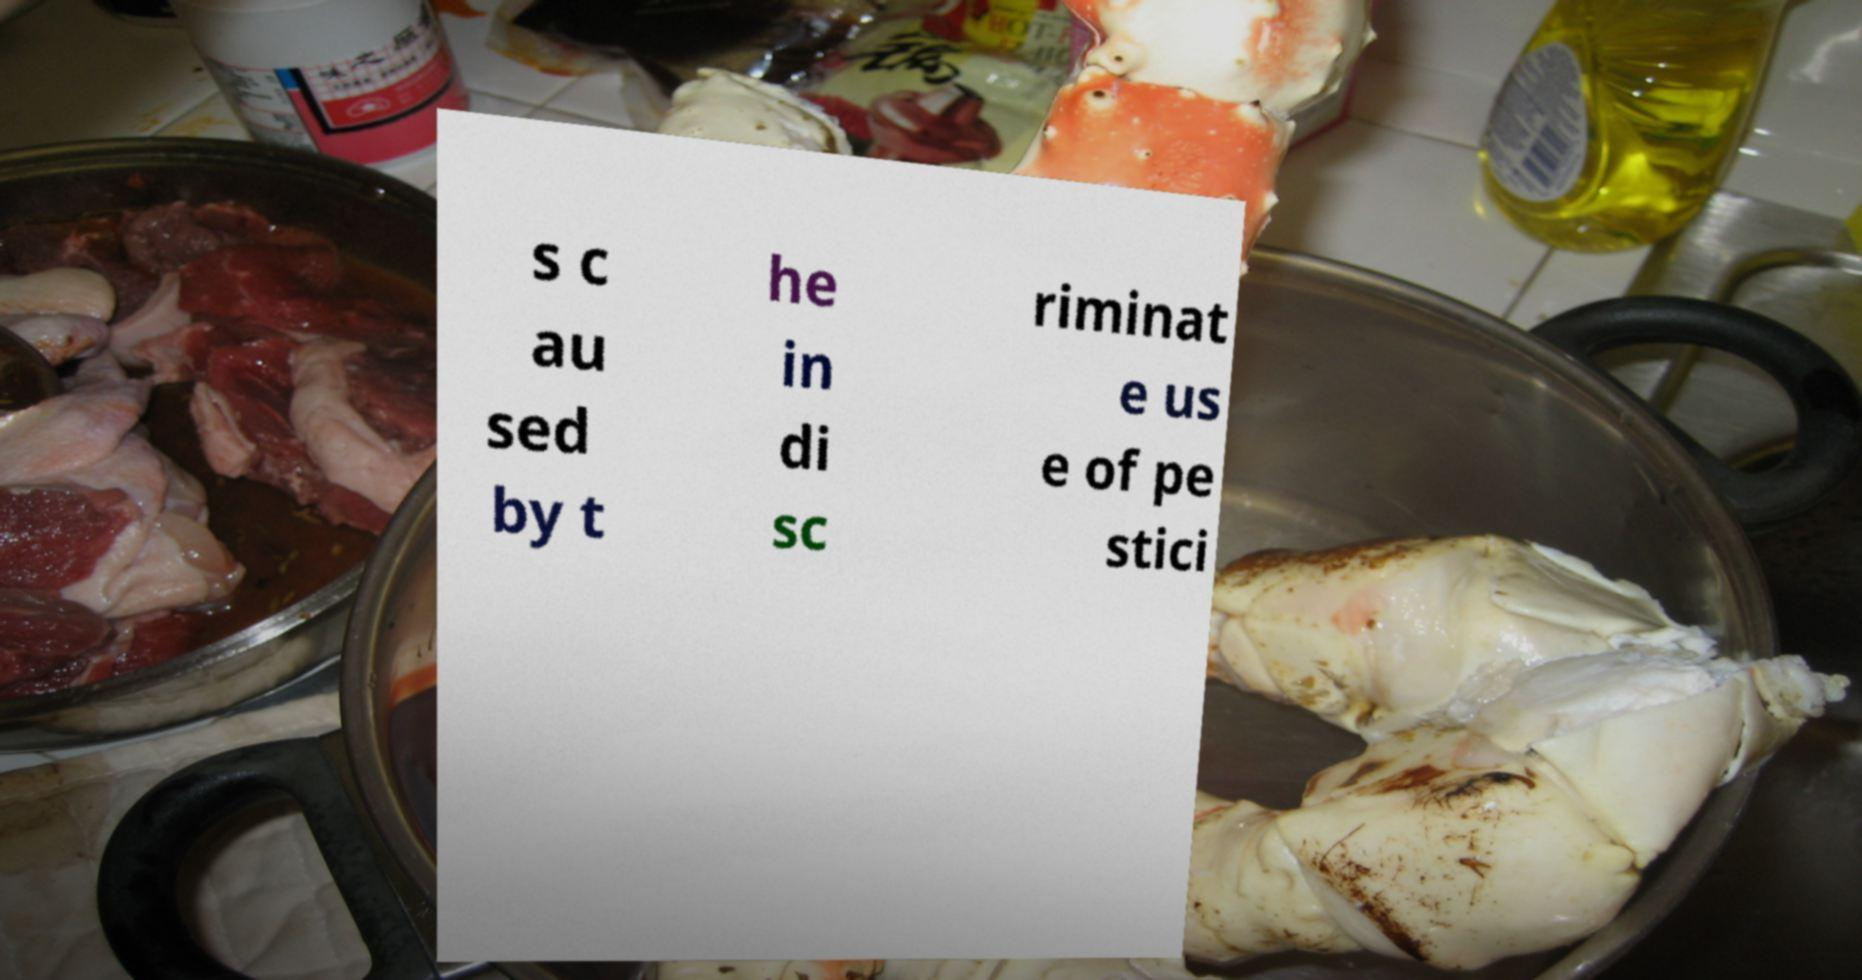Could you assist in decoding the text presented in this image and type it out clearly? s c au sed by t he in di sc riminat e us e of pe stici 